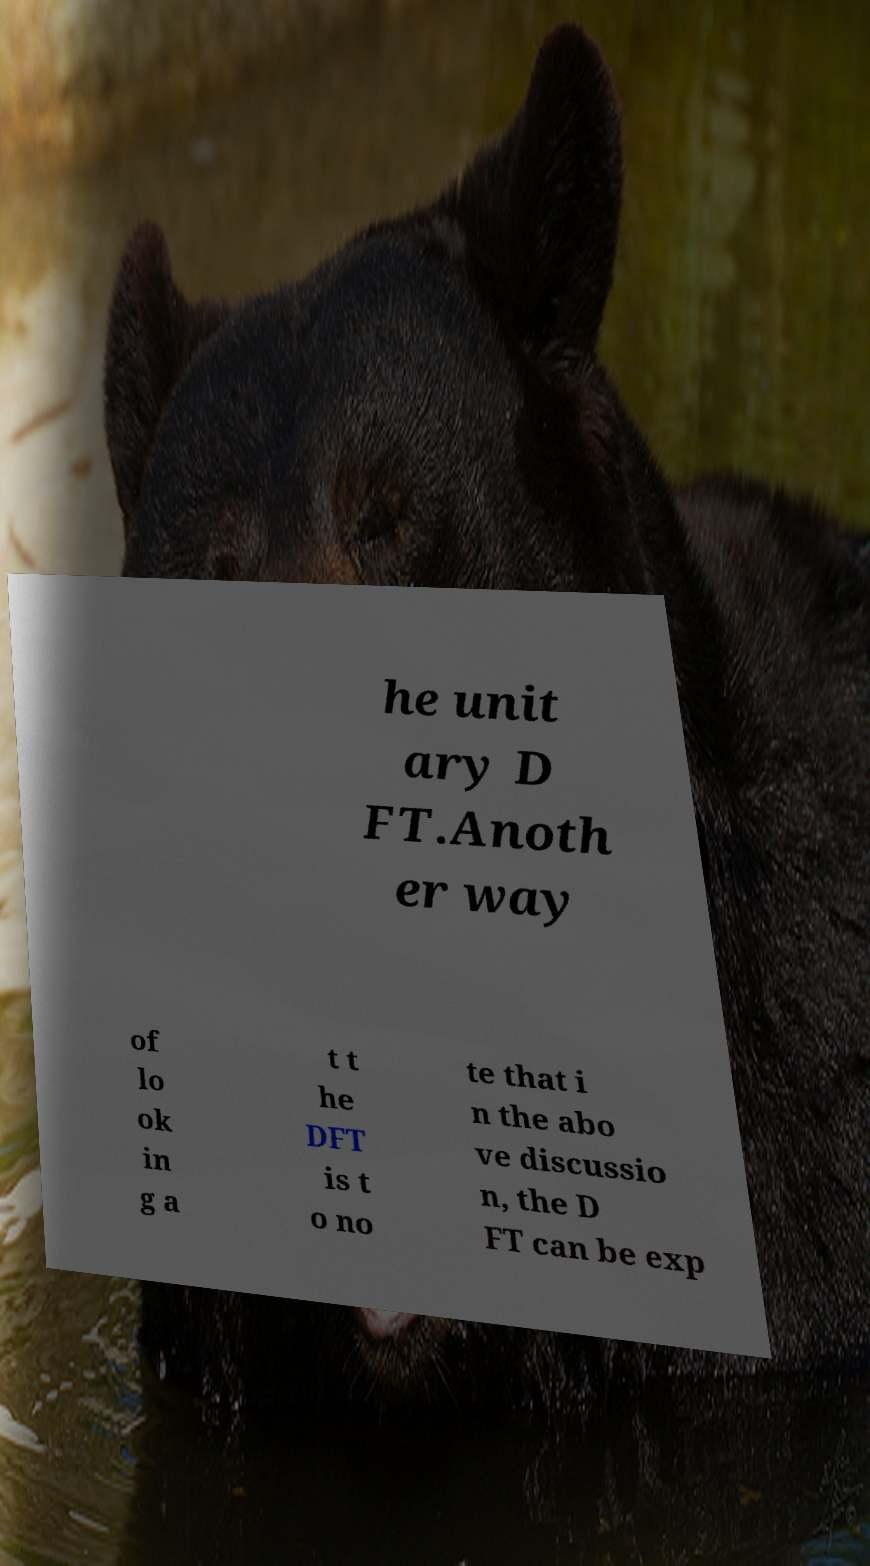I need the written content from this picture converted into text. Can you do that? he unit ary D FT.Anoth er way of lo ok in g a t t he DFT is t o no te that i n the abo ve discussio n, the D FT can be exp 